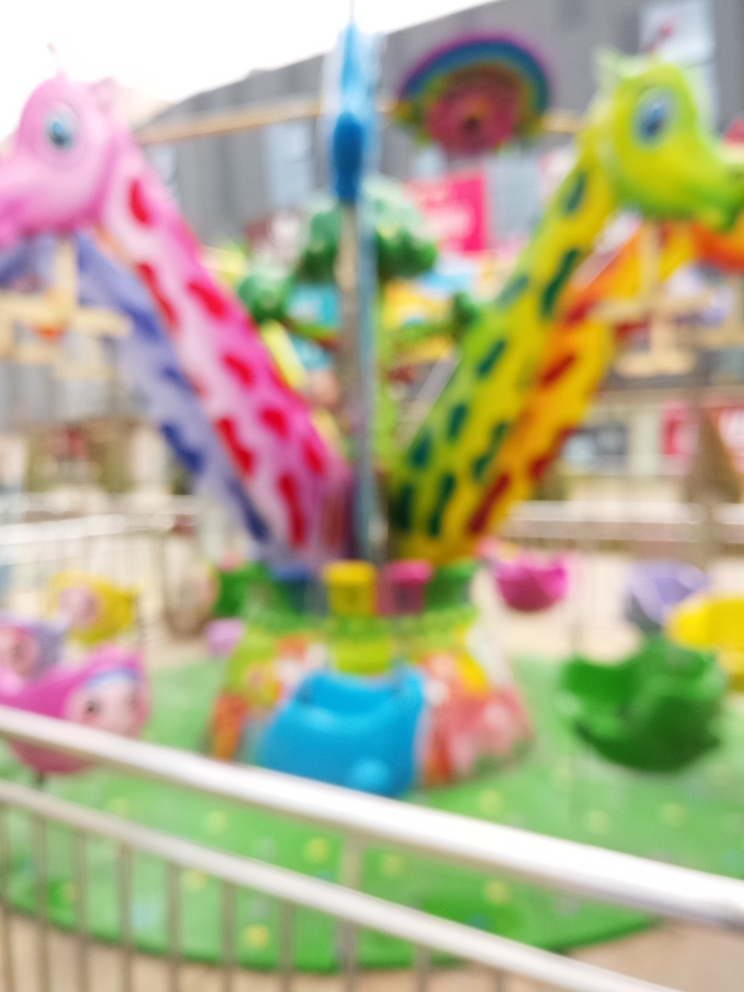Can you describe what this blurry image might contain? The image appears to capture a carousel, likely taken with a slow shutter speed or while in motion, resulting in a blurred effect. The bright, assorted colors suggest that it's designed for children, with vibrant sculptures of animals, possibly horses, mounted on a rotating platform. Although the specific details are indistinct, the whimsical nature of the ride and its blurred motion give it a dreamlike or nostalgic quality. 